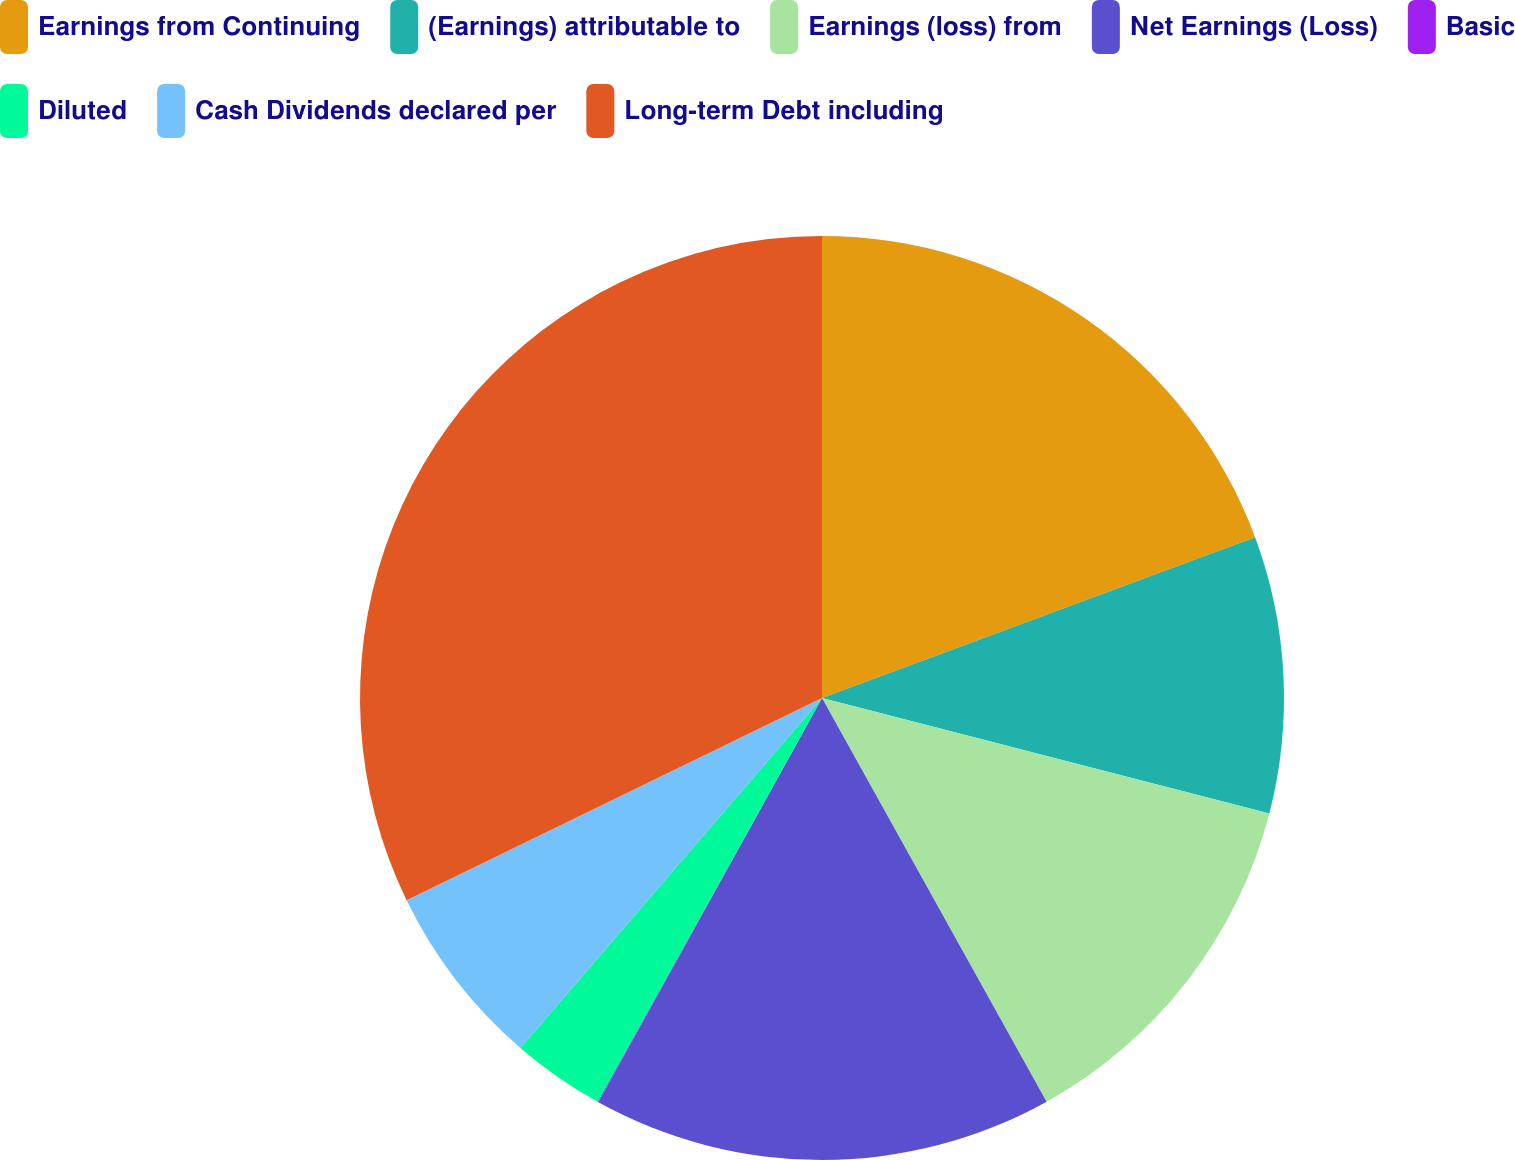Convert chart. <chart><loc_0><loc_0><loc_500><loc_500><pie_chart><fcel>Earnings from Continuing<fcel>(Earnings) attributable to<fcel>Earnings (loss) from<fcel>Net Earnings (Loss)<fcel>Basic<fcel>Diluted<fcel>Cash Dividends declared per<fcel>Long-term Debt including<nl><fcel>19.34%<fcel>9.68%<fcel>12.9%<fcel>16.12%<fcel>0.03%<fcel>3.25%<fcel>6.47%<fcel>32.21%<nl></chart> 